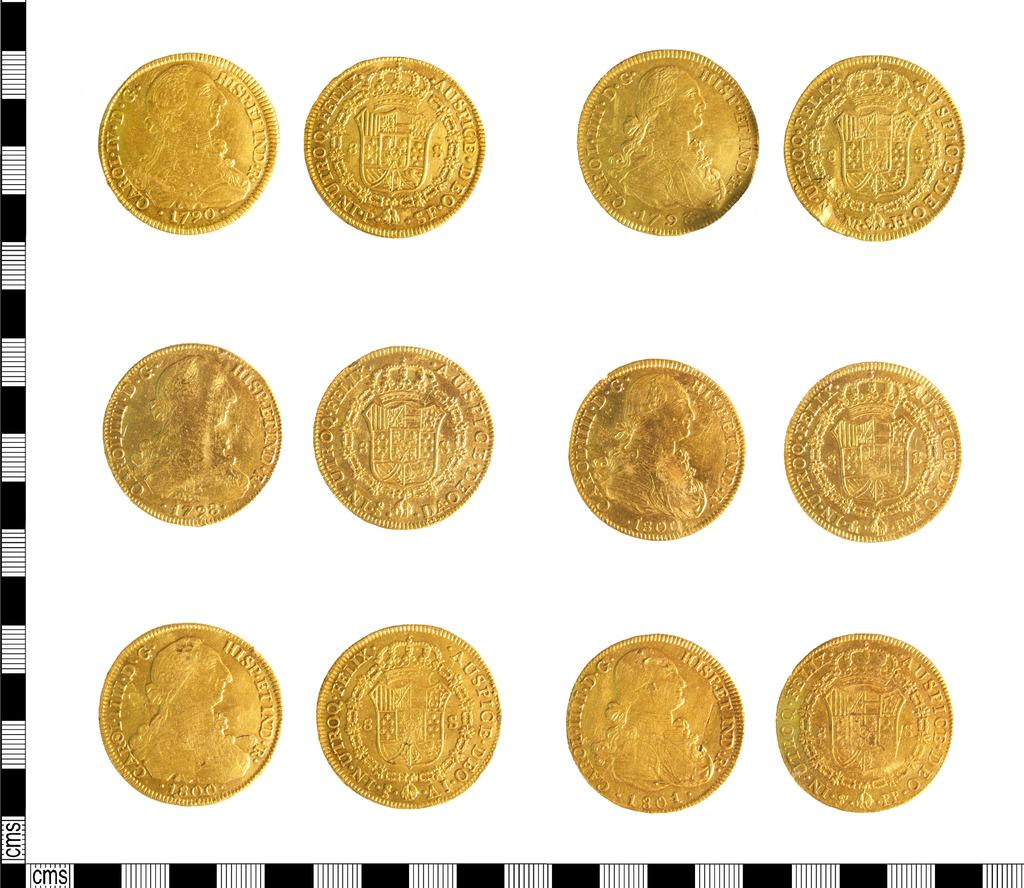<image>
Summarize the visual content of the image. rows of gold coins with one of them labeled 'caroi' 